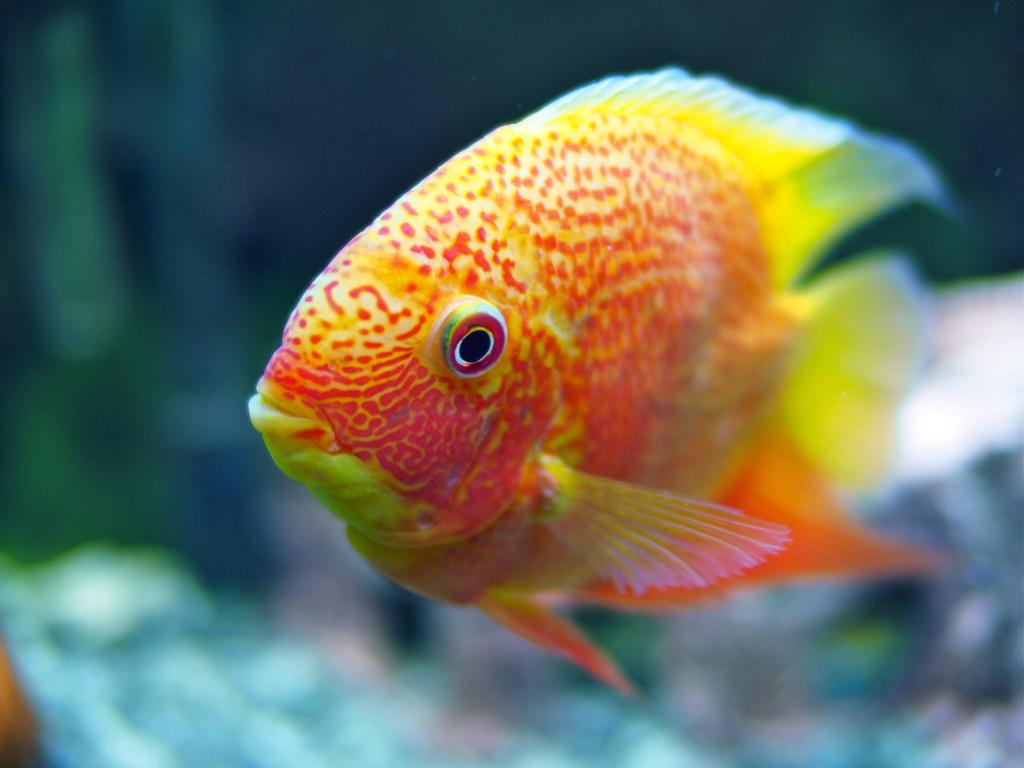What type of animal is present in the image? There is a fish in the image. Can you describe the color shades of the fish? The fish has orange and yellow color shades. How many legs does the fish have in the image? Fish do not have legs, so the fish in the image does not have any legs. What type of wave can be seen in the image? There is no wave present in the image; it features a fish with orange and yellow color shades. 